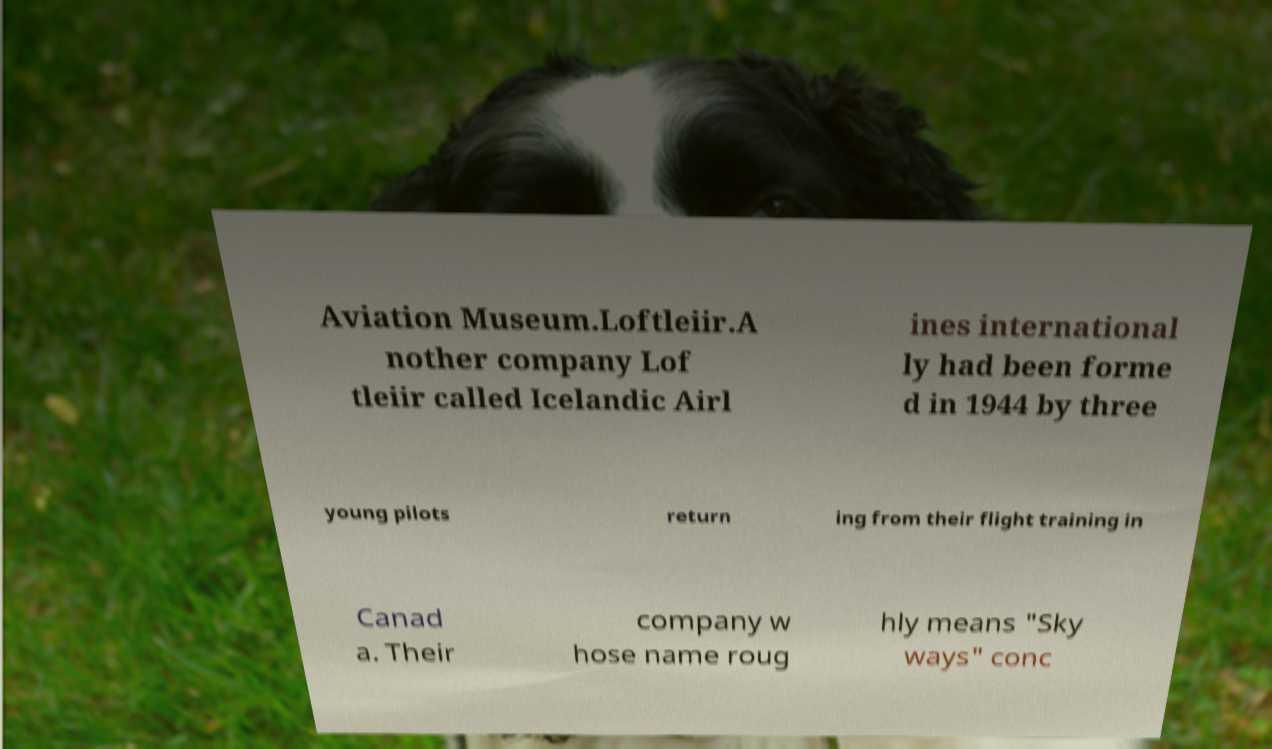There's text embedded in this image that I need extracted. Can you transcribe it verbatim? Aviation Museum.Loftleiir.A nother company Lof tleiir called Icelandic Airl ines international ly had been forme d in 1944 by three young pilots return ing from their flight training in Canad a. Their company w hose name roug hly means "Sky ways" conc 